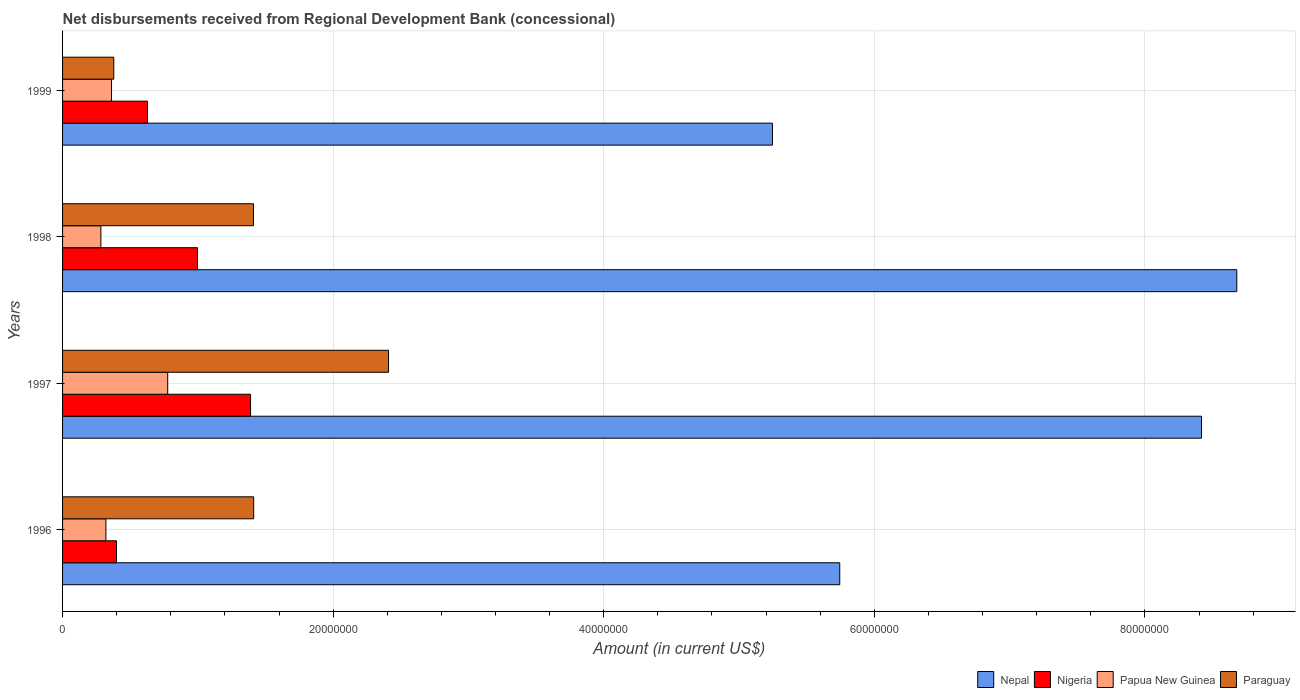What is the label of the 3rd group of bars from the top?
Provide a succinct answer. 1997. In how many cases, is the number of bars for a given year not equal to the number of legend labels?
Make the answer very short. 0. What is the amount of disbursements received from Regional Development Bank in Papua New Guinea in 1997?
Give a very brief answer. 7.77e+06. Across all years, what is the maximum amount of disbursements received from Regional Development Bank in Papua New Guinea?
Your response must be concise. 7.77e+06. Across all years, what is the minimum amount of disbursements received from Regional Development Bank in Paraguay?
Your answer should be compact. 3.79e+06. In which year was the amount of disbursements received from Regional Development Bank in Nepal minimum?
Give a very brief answer. 1999. What is the total amount of disbursements received from Regional Development Bank in Nepal in the graph?
Ensure brevity in your answer.  2.81e+08. What is the difference between the amount of disbursements received from Regional Development Bank in Papua New Guinea in 1996 and that in 1998?
Your response must be concise. 3.70e+05. What is the difference between the amount of disbursements received from Regional Development Bank in Papua New Guinea in 1997 and the amount of disbursements received from Regional Development Bank in Paraguay in 1999?
Your answer should be compact. 3.98e+06. What is the average amount of disbursements received from Regional Development Bank in Papua New Guinea per year?
Give a very brief answer. 4.36e+06. In the year 1999, what is the difference between the amount of disbursements received from Regional Development Bank in Paraguay and amount of disbursements received from Regional Development Bank in Papua New Guinea?
Offer a terse response. 1.69e+05. What is the ratio of the amount of disbursements received from Regional Development Bank in Papua New Guinea in 1996 to that in 1999?
Provide a short and direct response. 0.89. Is the amount of disbursements received from Regional Development Bank in Papua New Guinea in 1996 less than that in 1997?
Your response must be concise. Yes. What is the difference between the highest and the second highest amount of disbursements received from Regional Development Bank in Nepal?
Offer a terse response. 2.61e+06. What is the difference between the highest and the lowest amount of disbursements received from Regional Development Bank in Nepal?
Offer a very short reply. 3.43e+07. What does the 1st bar from the top in 1999 represents?
Provide a short and direct response. Paraguay. What does the 3rd bar from the bottom in 1998 represents?
Your answer should be very brief. Papua New Guinea. Is it the case that in every year, the sum of the amount of disbursements received from Regional Development Bank in Paraguay and amount of disbursements received from Regional Development Bank in Nigeria is greater than the amount of disbursements received from Regional Development Bank in Nepal?
Provide a short and direct response. No. Are the values on the major ticks of X-axis written in scientific E-notation?
Make the answer very short. No. Does the graph contain any zero values?
Your response must be concise. No. Does the graph contain grids?
Provide a succinct answer. Yes. Where does the legend appear in the graph?
Give a very brief answer. Bottom right. How many legend labels are there?
Keep it short and to the point. 4. How are the legend labels stacked?
Your answer should be compact. Horizontal. What is the title of the graph?
Your response must be concise. Net disbursements received from Regional Development Bank (concessional). What is the label or title of the X-axis?
Provide a succinct answer. Amount (in current US$). What is the Amount (in current US$) in Nepal in 1996?
Provide a short and direct response. 5.74e+07. What is the Amount (in current US$) in Nigeria in 1996?
Your answer should be very brief. 3.98e+06. What is the Amount (in current US$) in Papua New Guinea in 1996?
Provide a short and direct response. 3.20e+06. What is the Amount (in current US$) in Paraguay in 1996?
Provide a short and direct response. 1.41e+07. What is the Amount (in current US$) of Nepal in 1997?
Ensure brevity in your answer.  8.42e+07. What is the Amount (in current US$) of Nigeria in 1997?
Give a very brief answer. 1.39e+07. What is the Amount (in current US$) of Papua New Guinea in 1997?
Offer a very short reply. 7.77e+06. What is the Amount (in current US$) of Paraguay in 1997?
Ensure brevity in your answer.  2.41e+07. What is the Amount (in current US$) of Nepal in 1998?
Make the answer very short. 8.68e+07. What is the Amount (in current US$) of Nigeria in 1998?
Keep it short and to the point. 9.97e+06. What is the Amount (in current US$) in Papua New Guinea in 1998?
Your answer should be compact. 2.83e+06. What is the Amount (in current US$) in Paraguay in 1998?
Provide a short and direct response. 1.41e+07. What is the Amount (in current US$) in Nepal in 1999?
Your answer should be compact. 5.25e+07. What is the Amount (in current US$) in Nigeria in 1999?
Provide a succinct answer. 6.28e+06. What is the Amount (in current US$) in Papua New Guinea in 1999?
Give a very brief answer. 3.62e+06. What is the Amount (in current US$) in Paraguay in 1999?
Your answer should be very brief. 3.79e+06. Across all years, what is the maximum Amount (in current US$) of Nepal?
Your answer should be compact. 8.68e+07. Across all years, what is the maximum Amount (in current US$) in Nigeria?
Offer a terse response. 1.39e+07. Across all years, what is the maximum Amount (in current US$) of Papua New Guinea?
Keep it short and to the point. 7.77e+06. Across all years, what is the maximum Amount (in current US$) of Paraguay?
Your answer should be compact. 2.41e+07. Across all years, what is the minimum Amount (in current US$) in Nepal?
Your response must be concise. 5.25e+07. Across all years, what is the minimum Amount (in current US$) of Nigeria?
Provide a succinct answer. 3.98e+06. Across all years, what is the minimum Amount (in current US$) of Papua New Guinea?
Keep it short and to the point. 2.83e+06. Across all years, what is the minimum Amount (in current US$) of Paraguay?
Ensure brevity in your answer.  3.79e+06. What is the total Amount (in current US$) of Nepal in the graph?
Provide a short and direct response. 2.81e+08. What is the total Amount (in current US$) of Nigeria in the graph?
Keep it short and to the point. 3.41e+07. What is the total Amount (in current US$) of Papua New Guinea in the graph?
Make the answer very short. 1.74e+07. What is the total Amount (in current US$) in Paraguay in the graph?
Offer a terse response. 5.61e+07. What is the difference between the Amount (in current US$) of Nepal in 1996 and that in 1997?
Your answer should be very brief. -2.67e+07. What is the difference between the Amount (in current US$) of Nigeria in 1996 and that in 1997?
Offer a terse response. -9.91e+06. What is the difference between the Amount (in current US$) in Papua New Guinea in 1996 and that in 1997?
Make the answer very short. -4.57e+06. What is the difference between the Amount (in current US$) of Paraguay in 1996 and that in 1997?
Make the answer very short. -9.97e+06. What is the difference between the Amount (in current US$) in Nepal in 1996 and that in 1998?
Your response must be concise. -2.93e+07. What is the difference between the Amount (in current US$) of Nigeria in 1996 and that in 1998?
Provide a succinct answer. -5.99e+06. What is the difference between the Amount (in current US$) in Papua New Guinea in 1996 and that in 1998?
Provide a short and direct response. 3.70e+05. What is the difference between the Amount (in current US$) of Paraguay in 1996 and that in 1998?
Keep it short and to the point. 1.70e+04. What is the difference between the Amount (in current US$) in Nepal in 1996 and that in 1999?
Your response must be concise. 4.98e+06. What is the difference between the Amount (in current US$) of Nigeria in 1996 and that in 1999?
Provide a short and direct response. -2.29e+06. What is the difference between the Amount (in current US$) of Papua New Guinea in 1996 and that in 1999?
Your response must be concise. -4.16e+05. What is the difference between the Amount (in current US$) of Paraguay in 1996 and that in 1999?
Give a very brief answer. 1.03e+07. What is the difference between the Amount (in current US$) in Nepal in 1997 and that in 1998?
Offer a terse response. -2.61e+06. What is the difference between the Amount (in current US$) of Nigeria in 1997 and that in 1998?
Offer a terse response. 3.92e+06. What is the difference between the Amount (in current US$) of Papua New Guinea in 1997 and that in 1998?
Make the answer very short. 4.94e+06. What is the difference between the Amount (in current US$) in Paraguay in 1997 and that in 1998?
Your answer should be very brief. 9.98e+06. What is the difference between the Amount (in current US$) in Nepal in 1997 and that in 1999?
Provide a short and direct response. 3.17e+07. What is the difference between the Amount (in current US$) in Nigeria in 1997 and that in 1999?
Ensure brevity in your answer.  7.62e+06. What is the difference between the Amount (in current US$) of Papua New Guinea in 1997 and that in 1999?
Make the answer very short. 4.15e+06. What is the difference between the Amount (in current US$) of Paraguay in 1997 and that in 1999?
Give a very brief answer. 2.03e+07. What is the difference between the Amount (in current US$) of Nepal in 1998 and that in 1999?
Your response must be concise. 3.43e+07. What is the difference between the Amount (in current US$) in Nigeria in 1998 and that in 1999?
Offer a terse response. 3.70e+06. What is the difference between the Amount (in current US$) of Papua New Guinea in 1998 and that in 1999?
Your answer should be compact. -7.86e+05. What is the difference between the Amount (in current US$) of Paraguay in 1998 and that in 1999?
Ensure brevity in your answer.  1.03e+07. What is the difference between the Amount (in current US$) of Nepal in 1996 and the Amount (in current US$) of Nigeria in 1997?
Ensure brevity in your answer.  4.36e+07. What is the difference between the Amount (in current US$) of Nepal in 1996 and the Amount (in current US$) of Papua New Guinea in 1997?
Offer a very short reply. 4.97e+07. What is the difference between the Amount (in current US$) in Nepal in 1996 and the Amount (in current US$) in Paraguay in 1997?
Offer a terse response. 3.34e+07. What is the difference between the Amount (in current US$) in Nigeria in 1996 and the Amount (in current US$) in Papua New Guinea in 1997?
Offer a very short reply. -3.79e+06. What is the difference between the Amount (in current US$) in Nigeria in 1996 and the Amount (in current US$) in Paraguay in 1997?
Keep it short and to the point. -2.01e+07. What is the difference between the Amount (in current US$) of Papua New Guinea in 1996 and the Amount (in current US$) of Paraguay in 1997?
Your answer should be very brief. -2.09e+07. What is the difference between the Amount (in current US$) of Nepal in 1996 and the Amount (in current US$) of Nigeria in 1998?
Offer a very short reply. 4.75e+07. What is the difference between the Amount (in current US$) in Nepal in 1996 and the Amount (in current US$) in Papua New Guinea in 1998?
Offer a terse response. 5.46e+07. What is the difference between the Amount (in current US$) of Nepal in 1996 and the Amount (in current US$) of Paraguay in 1998?
Keep it short and to the point. 4.33e+07. What is the difference between the Amount (in current US$) in Nigeria in 1996 and the Amount (in current US$) in Papua New Guinea in 1998?
Your answer should be very brief. 1.15e+06. What is the difference between the Amount (in current US$) of Nigeria in 1996 and the Amount (in current US$) of Paraguay in 1998?
Your response must be concise. -1.01e+07. What is the difference between the Amount (in current US$) of Papua New Guinea in 1996 and the Amount (in current US$) of Paraguay in 1998?
Provide a short and direct response. -1.09e+07. What is the difference between the Amount (in current US$) of Nepal in 1996 and the Amount (in current US$) of Nigeria in 1999?
Offer a very short reply. 5.12e+07. What is the difference between the Amount (in current US$) in Nepal in 1996 and the Amount (in current US$) in Papua New Guinea in 1999?
Give a very brief answer. 5.38e+07. What is the difference between the Amount (in current US$) of Nepal in 1996 and the Amount (in current US$) of Paraguay in 1999?
Provide a short and direct response. 5.37e+07. What is the difference between the Amount (in current US$) in Nigeria in 1996 and the Amount (in current US$) in Papua New Guinea in 1999?
Make the answer very short. 3.67e+05. What is the difference between the Amount (in current US$) in Nigeria in 1996 and the Amount (in current US$) in Paraguay in 1999?
Your answer should be very brief. 1.98e+05. What is the difference between the Amount (in current US$) in Papua New Guinea in 1996 and the Amount (in current US$) in Paraguay in 1999?
Your response must be concise. -5.85e+05. What is the difference between the Amount (in current US$) of Nepal in 1997 and the Amount (in current US$) of Nigeria in 1998?
Provide a short and direct response. 7.42e+07. What is the difference between the Amount (in current US$) in Nepal in 1997 and the Amount (in current US$) in Papua New Guinea in 1998?
Your answer should be very brief. 8.14e+07. What is the difference between the Amount (in current US$) in Nepal in 1997 and the Amount (in current US$) in Paraguay in 1998?
Your response must be concise. 7.01e+07. What is the difference between the Amount (in current US$) in Nigeria in 1997 and the Amount (in current US$) in Papua New Guinea in 1998?
Your answer should be compact. 1.11e+07. What is the difference between the Amount (in current US$) of Nigeria in 1997 and the Amount (in current US$) of Paraguay in 1998?
Keep it short and to the point. -2.13e+05. What is the difference between the Amount (in current US$) in Papua New Guinea in 1997 and the Amount (in current US$) in Paraguay in 1998?
Offer a terse response. -6.34e+06. What is the difference between the Amount (in current US$) in Nepal in 1997 and the Amount (in current US$) in Nigeria in 1999?
Your answer should be compact. 7.79e+07. What is the difference between the Amount (in current US$) of Nepal in 1997 and the Amount (in current US$) of Papua New Guinea in 1999?
Keep it short and to the point. 8.06e+07. What is the difference between the Amount (in current US$) of Nepal in 1997 and the Amount (in current US$) of Paraguay in 1999?
Offer a very short reply. 8.04e+07. What is the difference between the Amount (in current US$) of Nigeria in 1997 and the Amount (in current US$) of Papua New Guinea in 1999?
Provide a succinct answer. 1.03e+07. What is the difference between the Amount (in current US$) in Nigeria in 1997 and the Amount (in current US$) in Paraguay in 1999?
Offer a very short reply. 1.01e+07. What is the difference between the Amount (in current US$) of Papua New Guinea in 1997 and the Amount (in current US$) of Paraguay in 1999?
Your answer should be very brief. 3.98e+06. What is the difference between the Amount (in current US$) of Nepal in 1998 and the Amount (in current US$) of Nigeria in 1999?
Ensure brevity in your answer.  8.05e+07. What is the difference between the Amount (in current US$) in Nepal in 1998 and the Amount (in current US$) in Papua New Guinea in 1999?
Make the answer very short. 8.32e+07. What is the difference between the Amount (in current US$) in Nepal in 1998 and the Amount (in current US$) in Paraguay in 1999?
Keep it short and to the point. 8.30e+07. What is the difference between the Amount (in current US$) of Nigeria in 1998 and the Amount (in current US$) of Papua New Guinea in 1999?
Ensure brevity in your answer.  6.35e+06. What is the difference between the Amount (in current US$) of Nigeria in 1998 and the Amount (in current US$) of Paraguay in 1999?
Offer a terse response. 6.18e+06. What is the difference between the Amount (in current US$) in Papua New Guinea in 1998 and the Amount (in current US$) in Paraguay in 1999?
Keep it short and to the point. -9.55e+05. What is the average Amount (in current US$) in Nepal per year?
Keep it short and to the point. 7.02e+07. What is the average Amount (in current US$) of Nigeria per year?
Provide a short and direct response. 8.53e+06. What is the average Amount (in current US$) of Papua New Guinea per year?
Your answer should be compact. 4.36e+06. What is the average Amount (in current US$) of Paraguay per year?
Your answer should be very brief. 1.40e+07. In the year 1996, what is the difference between the Amount (in current US$) of Nepal and Amount (in current US$) of Nigeria?
Your answer should be compact. 5.35e+07. In the year 1996, what is the difference between the Amount (in current US$) of Nepal and Amount (in current US$) of Papua New Guinea?
Provide a short and direct response. 5.42e+07. In the year 1996, what is the difference between the Amount (in current US$) in Nepal and Amount (in current US$) in Paraguay?
Ensure brevity in your answer.  4.33e+07. In the year 1996, what is the difference between the Amount (in current US$) in Nigeria and Amount (in current US$) in Papua New Guinea?
Ensure brevity in your answer.  7.83e+05. In the year 1996, what is the difference between the Amount (in current US$) of Nigeria and Amount (in current US$) of Paraguay?
Ensure brevity in your answer.  -1.01e+07. In the year 1996, what is the difference between the Amount (in current US$) in Papua New Guinea and Amount (in current US$) in Paraguay?
Make the answer very short. -1.09e+07. In the year 1997, what is the difference between the Amount (in current US$) of Nepal and Amount (in current US$) of Nigeria?
Give a very brief answer. 7.03e+07. In the year 1997, what is the difference between the Amount (in current US$) in Nepal and Amount (in current US$) in Papua New Guinea?
Ensure brevity in your answer.  7.64e+07. In the year 1997, what is the difference between the Amount (in current US$) of Nepal and Amount (in current US$) of Paraguay?
Make the answer very short. 6.01e+07. In the year 1997, what is the difference between the Amount (in current US$) in Nigeria and Amount (in current US$) in Papua New Guinea?
Keep it short and to the point. 6.12e+06. In the year 1997, what is the difference between the Amount (in current US$) of Nigeria and Amount (in current US$) of Paraguay?
Offer a very short reply. -1.02e+07. In the year 1997, what is the difference between the Amount (in current US$) of Papua New Guinea and Amount (in current US$) of Paraguay?
Your answer should be compact. -1.63e+07. In the year 1998, what is the difference between the Amount (in current US$) of Nepal and Amount (in current US$) of Nigeria?
Your response must be concise. 7.68e+07. In the year 1998, what is the difference between the Amount (in current US$) of Nepal and Amount (in current US$) of Papua New Guinea?
Offer a very short reply. 8.40e+07. In the year 1998, what is the difference between the Amount (in current US$) of Nepal and Amount (in current US$) of Paraguay?
Ensure brevity in your answer.  7.27e+07. In the year 1998, what is the difference between the Amount (in current US$) in Nigeria and Amount (in current US$) in Papua New Guinea?
Provide a short and direct response. 7.14e+06. In the year 1998, what is the difference between the Amount (in current US$) of Nigeria and Amount (in current US$) of Paraguay?
Your answer should be very brief. -4.14e+06. In the year 1998, what is the difference between the Amount (in current US$) of Papua New Guinea and Amount (in current US$) of Paraguay?
Your answer should be very brief. -1.13e+07. In the year 1999, what is the difference between the Amount (in current US$) of Nepal and Amount (in current US$) of Nigeria?
Ensure brevity in your answer.  4.62e+07. In the year 1999, what is the difference between the Amount (in current US$) of Nepal and Amount (in current US$) of Papua New Guinea?
Provide a short and direct response. 4.89e+07. In the year 1999, what is the difference between the Amount (in current US$) in Nepal and Amount (in current US$) in Paraguay?
Give a very brief answer. 4.87e+07. In the year 1999, what is the difference between the Amount (in current US$) of Nigeria and Amount (in current US$) of Papua New Guinea?
Your answer should be very brief. 2.66e+06. In the year 1999, what is the difference between the Amount (in current US$) in Nigeria and Amount (in current US$) in Paraguay?
Give a very brief answer. 2.49e+06. In the year 1999, what is the difference between the Amount (in current US$) in Papua New Guinea and Amount (in current US$) in Paraguay?
Your answer should be very brief. -1.69e+05. What is the ratio of the Amount (in current US$) in Nepal in 1996 to that in 1997?
Your answer should be very brief. 0.68. What is the ratio of the Amount (in current US$) of Nigeria in 1996 to that in 1997?
Offer a terse response. 0.29. What is the ratio of the Amount (in current US$) in Papua New Guinea in 1996 to that in 1997?
Your answer should be compact. 0.41. What is the ratio of the Amount (in current US$) in Paraguay in 1996 to that in 1997?
Offer a very short reply. 0.59. What is the ratio of the Amount (in current US$) of Nepal in 1996 to that in 1998?
Make the answer very short. 0.66. What is the ratio of the Amount (in current US$) of Nigeria in 1996 to that in 1998?
Keep it short and to the point. 0.4. What is the ratio of the Amount (in current US$) in Papua New Guinea in 1996 to that in 1998?
Ensure brevity in your answer.  1.13. What is the ratio of the Amount (in current US$) of Paraguay in 1996 to that in 1998?
Keep it short and to the point. 1. What is the ratio of the Amount (in current US$) in Nepal in 1996 to that in 1999?
Ensure brevity in your answer.  1.09. What is the ratio of the Amount (in current US$) in Nigeria in 1996 to that in 1999?
Give a very brief answer. 0.63. What is the ratio of the Amount (in current US$) of Papua New Guinea in 1996 to that in 1999?
Provide a short and direct response. 0.89. What is the ratio of the Amount (in current US$) in Paraguay in 1996 to that in 1999?
Your answer should be very brief. 3.73. What is the ratio of the Amount (in current US$) of Nepal in 1997 to that in 1998?
Ensure brevity in your answer.  0.97. What is the ratio of the Amount (in current US$) in Nigeria in 1997 to that in 1998?
Your answer should be compact. 1.39. What is the ratio of the Amount (in current US$) in Papua New Guinea in 1997 to that in 1998?
Keep it short and to the point. 2.74. What is the ratio of the Amount (in current US$) in Paraguay in 1997 to that in 1998?
Keep it short and to the point. 1.71. What is the ratio of the Amount (in current US$) of Nepal in 1997 to that in 1999?
Make the answer very short. 1.6. What is the ratio of the Amount (in current US$) in Nigeria in 1997 to that in 1999?
Keep it short and to the point. 2.21. What is the ratio of the Amount (in current US$) of Papua New Guinea in 1997 to that in 1999?
Provide a short and direct response. 2.15. What is the ratio of the Amount (in current US$) of Paraguay in 1997 to that in 1999?
Give a very brief answer. 6.36. What is the ratio of the Amount (in current US$) of Nepal in 1998 to that in 1999?
Ensure brevity in your answer.  1.65. What is the ratio of the Amount (in current US$) of Nigeria in 1998 to that in 1999?
Your answer should be compact. 1.59. What is the ratio of the Amount (in current US$) of Papua New Guinea in 1998 to that in 1999?
Your answer should be compact. 0.78. What is the ratio of the Amount (in current US$) of Paraguay in 1998 to that in 1999?
Offer a very short reply. 3.73. What is the difference between the highest and the second highest Amount (in current US$) in Nepal?
Provide a short and direct response. 2.61e+06. What is the difference between the highest and the second highest Amount (in current US$) in Nigeria?
Provide a succinct answer. 3.92e+06. What is the difference between the highest and the second highest Amount (in current US$) of Papua New Guinea?
Make the answer very short. 4.15e+06. What is the difference between the highest and the second highest Amount (in current US$) in Paraguay?
Offer a very short reply. 9.97e+06. What is the difference between the highest and the lowest Amount (in current US$) of Nepal?
Keep it short and to the point. 3.43e+07. What is the difference between the highest and the lowest Amount (in current US$) in Nigeria?
Keep it short and to the point. 9.91e+06. What is the difference between the highest and the lowest Amount (in current US$) in Papua New Guinea?
Your response must be concise. 4.94e+06. What is the difference between the highest and the lowest Amount (in current US$) in Paraguay?
Your response must be concise. 2.03e+07. 